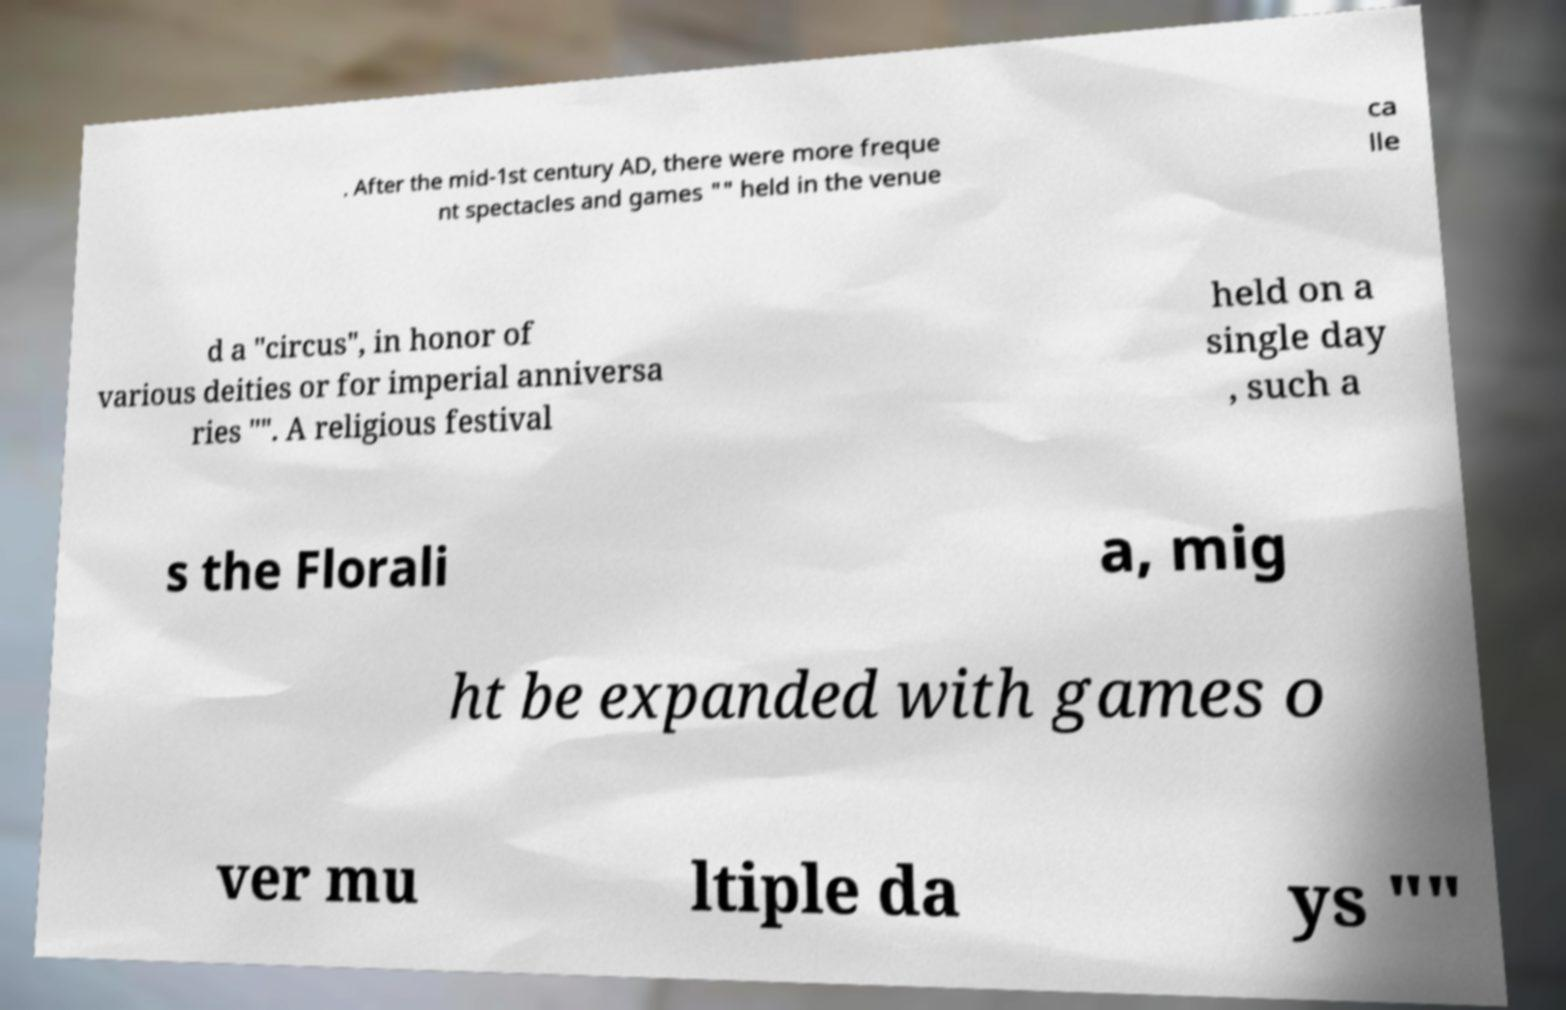Please identify and transcribe the text found in this image. . After the mid-1st century AD, there were more freque nt spectacles and games "" held in the venue ca lle d a "circus", in honor of various deities or for imperial anniversa ries "". A religious festival held on a single day , such a s the Florali a, mig ht be expanded with games o ver mu ltiple da ys "" 